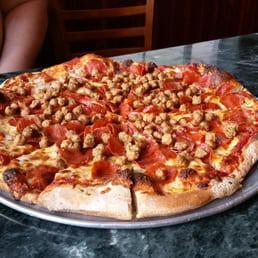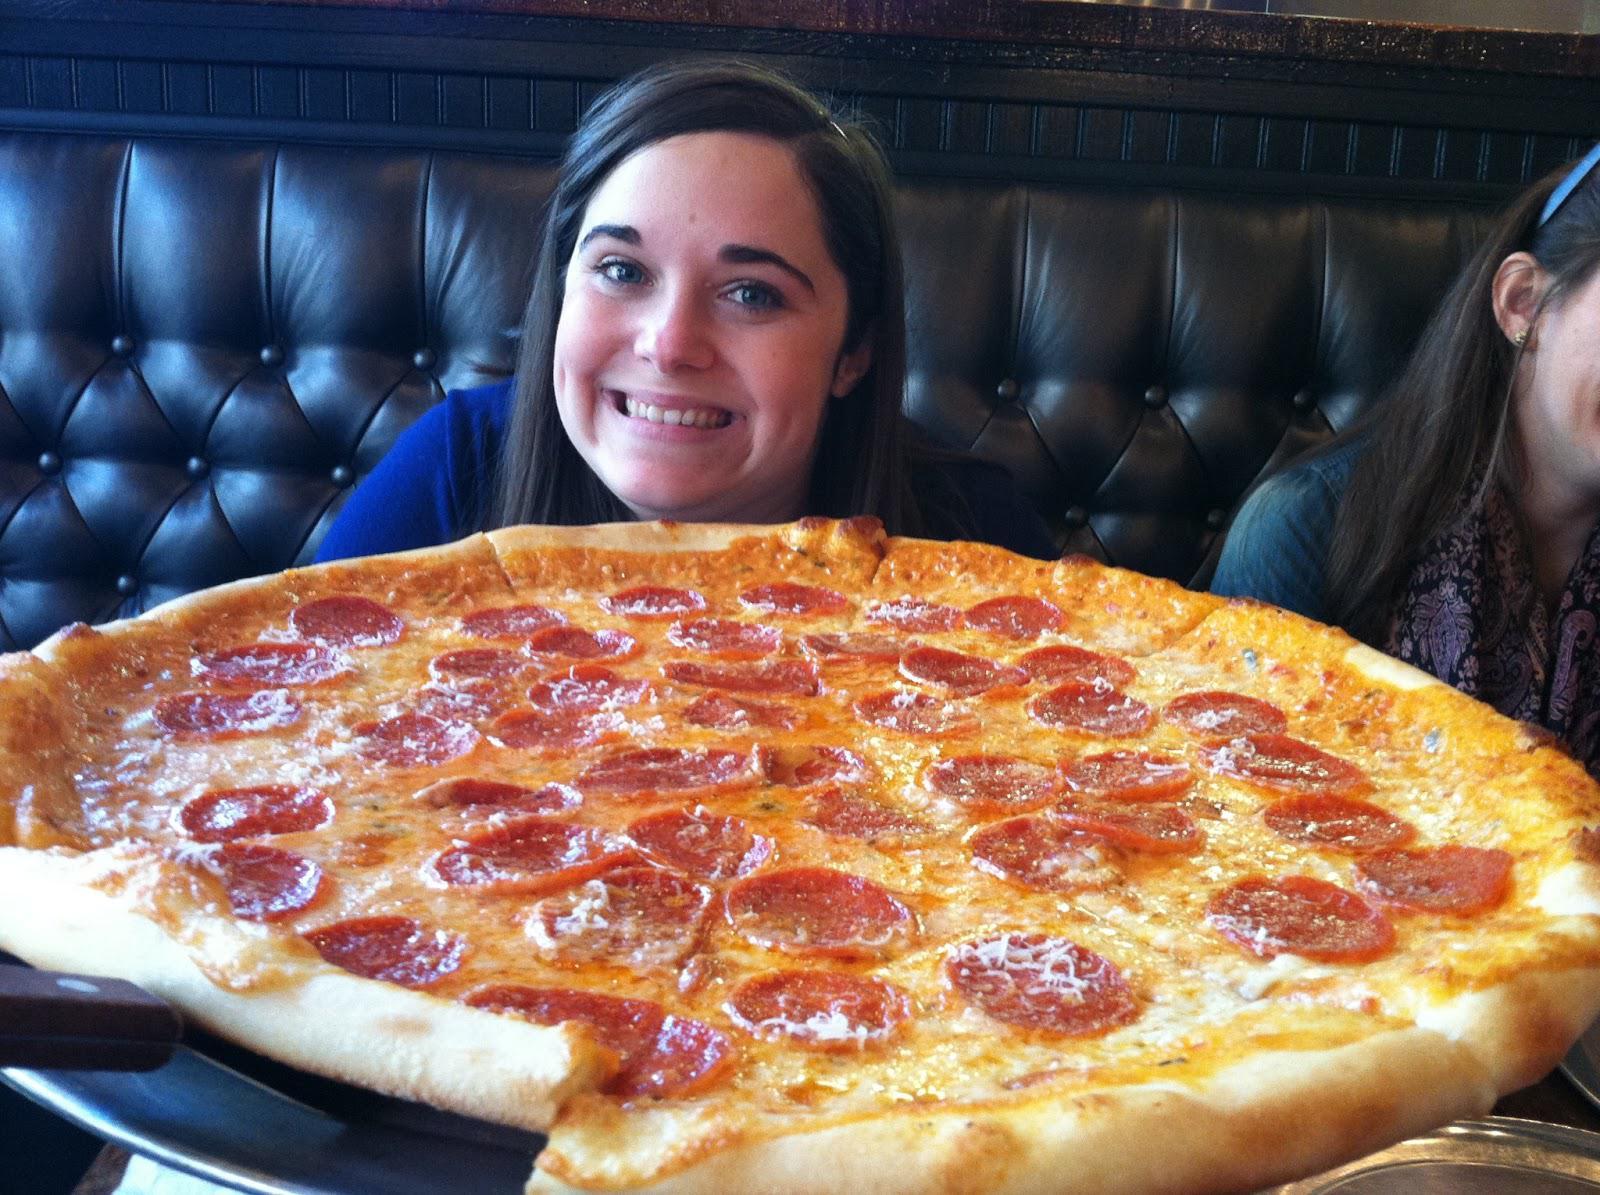The first image is the image on the left, the second image is the image on the right. Assess this claim about the two images: "The pizza in the image on the right is topped with round pepperoni slices.". Correct or not? Answer yes or no. Yes. The first image is the image on the left, the second image is the image on the right. Evaluate the accuracy of this statement regarding the images: "One image shows a whole pizza, and the other image shows a pizza on a round gray tray, with multiple slices missing.". Is it true? Answer yes or no. No. 